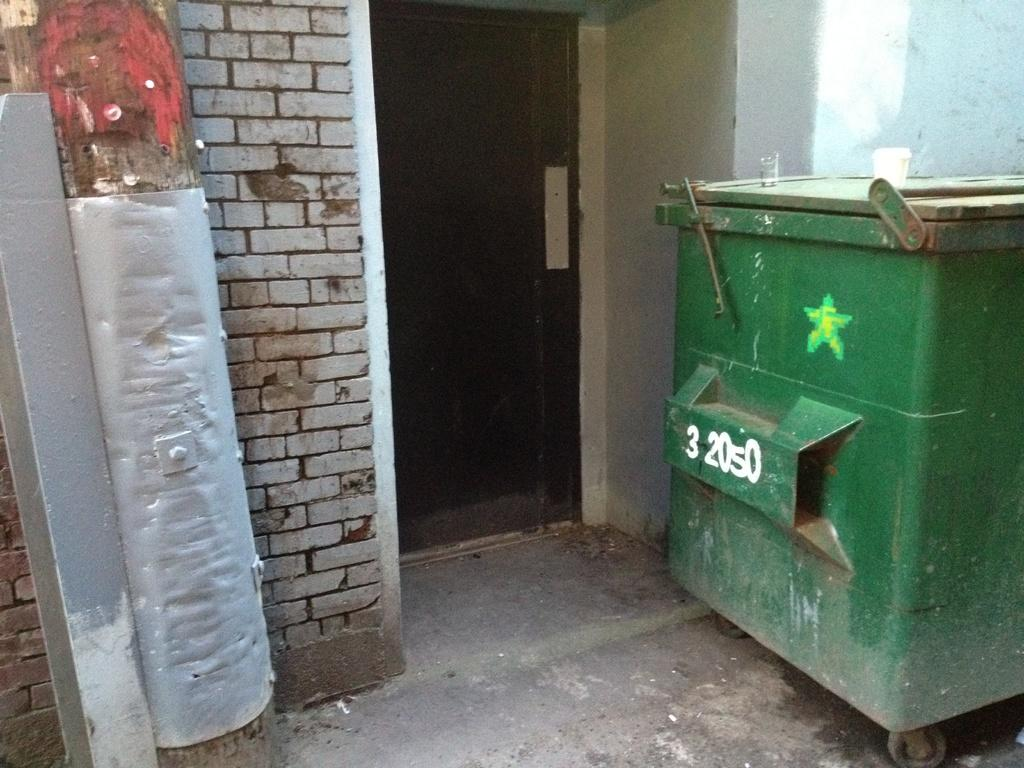<image>
Give a short and clear explanation of the subsequent image. A green dumpster has the numbers 32050 painted on its side. 